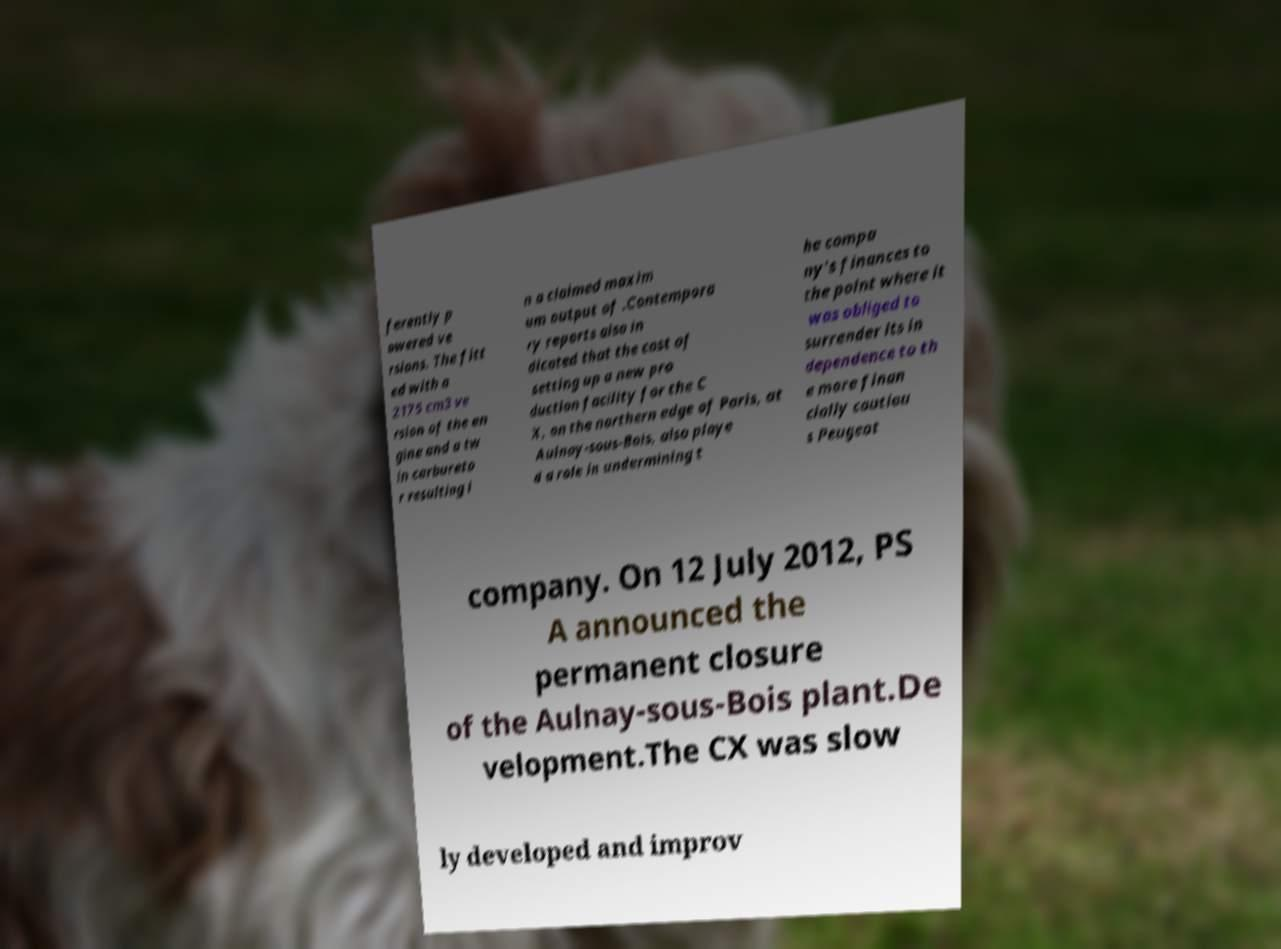There's text embedded in this image that I need extracted. Can you transcribe it verbatim? ferently p owered ve rsions. The fitt ed with a 2175 cm3 ve rsion of the en gine and a tw in carbureto r resulting i n a claimed maxim um output of .Contempora ry reports also in dicated that the cost of setting up a new pro duction facility for the C X, on the northern edge of Paris, at Aulnay-sous-Bois, also playe d a role in undermining t he compa ny's finances to the point where it was obliged to surrender its in dependence to th e more finan cially cautiou s Peugeot company. On 12 July 2012, PS A announced the permanent closure of the Aulnay-sous-Bois plant.De velopment.The CX was slow ly developed and improv 